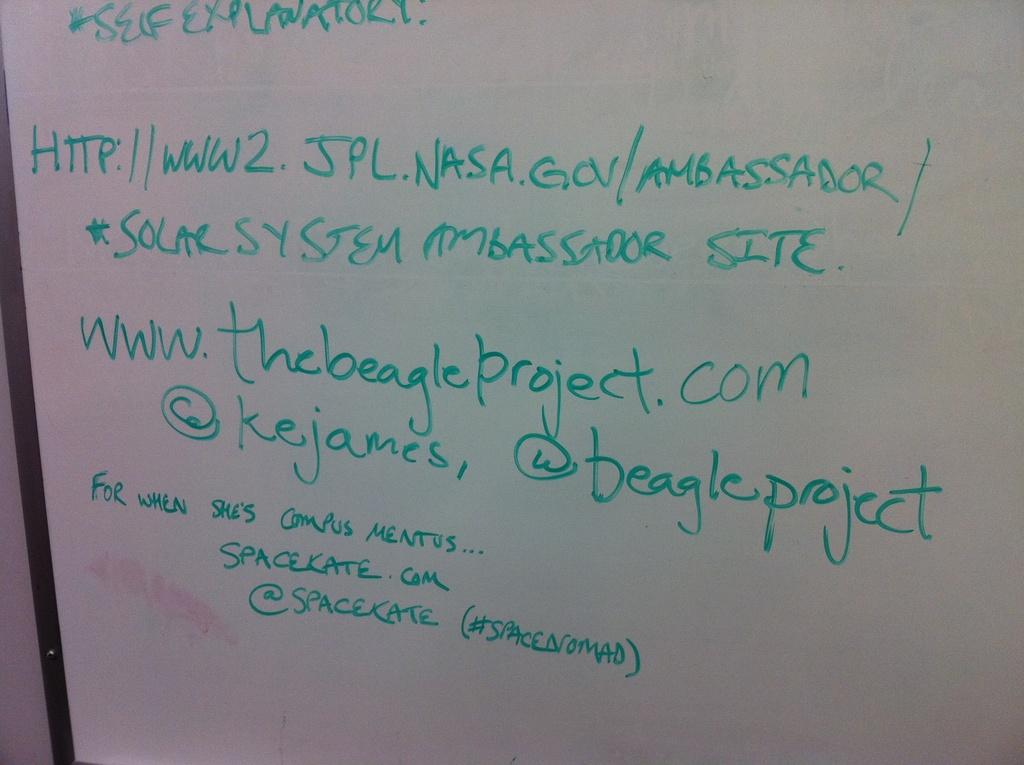Provide a one-sentence caption for the provided image. The ambassador of Solar System and the beagle project is sharing her site information. 